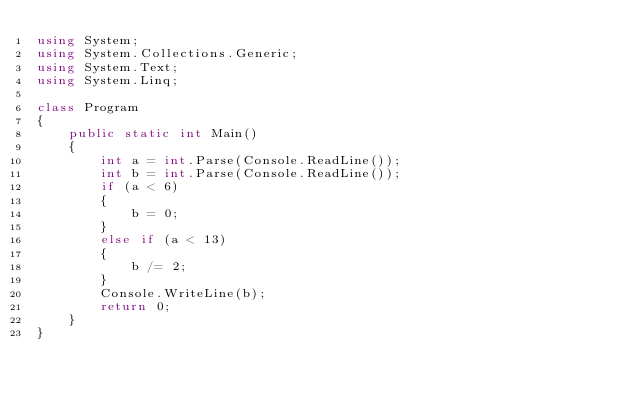<code> <loc_0><loc_0><loc_500><loc_500><_C#_>using System;
using System.Collections.Generic;
using System.Text;
using System.Linq;

class Program
{
    public static int Main()
    {
        int a = int.Parse(Console.ReadLine());
        int b = int.Parse(Console.ReadLine());
        if (a < 6)
        {
            b = 0;
        }
        else if (a < 13)
        {
            b /= 2;
        }
        Console.WriteLine(b);
        return 0;
    }
}
</code> 